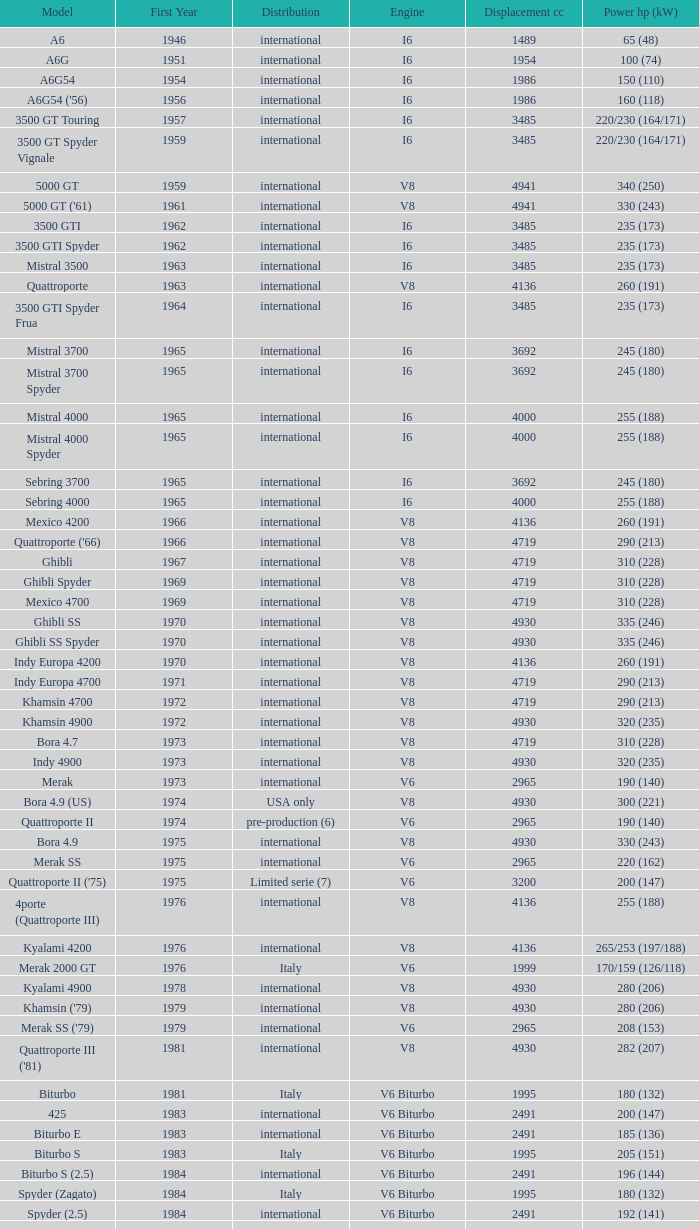What is Power HP (kW), when First Year is greater than 1965, when Distribution is "International", when Engine is V6 Biturbo, and when Model is "425"? 200 (147). Could you parse the entire table? {'header': ['Model', 'First Year', 'Distribution', 'Engine', 'Displacement cc', 'Power hp (kW)'], 'rows': [['A6', '1946', 'international', 'I6', '1489', '65 (48)'], ['A6G', '1951', 'international', 'I6', '1954', '100 (74)'], ['A6G54', '1954', 'international', 'I6', '1986', '150 (110)'], ["A6G54 ('56)", '1956', 'international', 'I6', '1986', '160 (118)'], ['3500 GT Touring', '1957', 'international', 'I6', '3485', '220/230 (164/171)'], ['3500 GT Spyder Vignale', '1959', 'international', 'I6', '3485', '220/230 (164/171)'], ['5000 GT', '1959', 'international', 'V8', '4941', '340 (250)'], ["5000 GT ('61)", '1961', 'international', 'V8', '4941', '330 (243)'], ['3500 GTI', '1962', 'international', 'I6', '3485', '235 (173)'], ['3500 GTI Spyder', '1962', 'international', 'I6', '3485', '235 (173)'], ['Mistral 3500', '1963', 'international', 'I6', '3485', '235 (173)'], ['Quattroporte', '1963', 'international', 'V8', '4136', '260 (191)'], ['3500 GTI Spyder Frua', '1964', 'international', 'I6', '3485', '235 (173)'], ['Mistral 3700', '1965', 'international', 'I6', '3692', '245 (180)'], ['Mistral 3700 Spyder', '1965', 'international', 'I6', '3692', '245 (180)'], ['Mistral 4000', '1965', 'international', 'I6', '4000', '255 (188)'], ['Mistral 4000 Spyder', '1965', 'international', 'I6', '4000', '255 (188)'], ['Sebring 3700', '1965', 'international', 'I6', '3692', '245 (180)'], ['Sebring 4000', '1965', 'international', 'I6', '4000', '255 (188)'], ['Mexico 4200', '1966', 'international', 'V8', '4136', '260 (191)'], ["Quattroporte ('66)", '1966', 'international', 'V8', '4719', '290 (213)'], ['Ghibli', '1967', 'international', 'V8', '4719', '310 (228)'], ['Ghibli Spyder', '1969', 'international', 'V8', '4719', '310 (228)'], ['Mexico 4700', '1969', 'international', 'V8', '4719', '310 (228)'], ['Ghibli SS', '1970', 'international', 'V8', '4930', '335 (246)'], ['Ghibli SS Spyder', '1970', 'international', 'V8', '4930', '335 (246)'], ['Indy Europa 4200', '1970', 'international', 'V8', '4136', '260 (191)'], ['Indy Europa 4700', '1971', 'international', 'V8', '4719', '290 (213)'], ['Khamsin 4700', '1972', 'international', 'V8', '4719', '290 (213)'], ['Khamsin 4900', '1972', 'international', 'V8', '4930', '320 (235)'], ['Bora 4.7', '1973', 'international', 'V8', '4719', '310 (228)'], ['Indy 4900', '1973', 'international', 'V8', '4930', '320 (235)'], ['Merak', '1973', 'international', 'V6', '2965', '190 (140)'], ['Bora 4.9 (US)', '1974', 'USA only', 'V8', '4930', '300 (221)'], ['Quattroporte II', '1974', 'pre-production (6)', 'V6', '2965', '190 (140)'], ['Bora 4.9', '1975', 'international', 'V8', '4930', '330 (243)'], ['Merak SS', '1975', 'international', 'V6', '2965', '220 (162)'], ["Quattroporte II ('75)", '1975', 'Limited serie (7)', 'V6', '3200', '200 (147)'], ['4porte (Quattroporte III)', '1976', 'international', 'V8', '4136', '255 (188)'], ['Kyalami 4200', '1976', 'international', 'V8', '4136', '265/253 (197/188)'], ['Merak 2000 GT', '1976', 'Italy', 'V6', '1999', '170/159 (126/118)'], ['Kyalami 4900', '1978', 'international', 'V8', '4930', '280 (206)'], ["Khamsin ('79)", '1979', 'international', 'V8', '4930', '280 (206)'], ["Merak SS ('79)", '1979', 'international', 'V6', '2965', '208 (153)'], ["Quattroporte III ('81)", '1981', 'international', 'V8', '4930', '282 (207)'], ['Biturbo', '1981', 'Italy', 'V6 Biturbo', '1995', '180 (132)'], ['425', '1983', 'international', 'V6 Biturbo', '2491', '200 (147)'], ['Biturbo E', '1983', 'international', 'V6 Biturbo', '2491', '185 (136)'], ['Biturbo S', '1983', 'Italy', 'V6 Biturbo', '1995', '205 (151)'], ['Biturbo S (2.5)', '1984', 'international', 'V6 Biturbo', '2491', '196 (144)'], ['Spyder (Zagato)', '1984', 'Italy', 'V6 Biturbo', '1995', '180 (132)'], ['Spyder (2.5)', '1984', 'international', 'V6 Biturbo', '2491', '192 (141)'], ['420', '1985', 'Italy', 'V6 Biturbo', '1995', '180 (132)'], ['Biturbo (II)', '1985', 'Italy', 'V6 Biturbo', '1995', '180 (132)'], ['Biturbo E (II 2.5)', '1985', 'international', 'V6 Biturbo', '2491', '185 (136)'], ['Biturbo S (II)', '1985', 'Italy', 'V6 Biturbo', '1995', '210 (154)'], ['228 (228i)', '1986', 'international', 'V6 Biturbo', '2790', '250 (184)'], ['228 (228i) Kat', '1986', 'international', 'V6 Biturbo', '2790', '225 (165)'], ['420i', '1986', 'Italy', 'V6 Biturbo', '1995', '190 (140)'], ['420 S', '1986', 'Italy', 'V6 Biturbo', '1995', '210 (154)'], ['Biturbo i', '1986', 'Italy', 'V6 Biturbo', '1995', '185 (136)'], ['Quattroporte Royale (III)', '1986', 'international', 'V8', '4930', '300 (221)'], ['Spyder i', '1986', 'international', 'V6 Biturbo', '1996', '185 (136)'], ['430', '1987', 'international', 'V6 Biturbo', '2790', '225 (165)'], ['425i', '1987', 'international', 'V6 Biturbo', '2491', '188 (138)'], ['Biturbo Si', '1987', 'Italy', 'V6 Biturbo', '1995', '220 (162)'], ['Biturbo Si (2.5)', '1987', 'international', 'V6 Biturbo', '2491', '188 (138)'], ["Spyder i ('87)", '1987', 'international', 'V6 Biturbo', '1996', '195 (143)'], ['222', '1988', 'Italy', 'V6 Biturbo', '1996', '220 (162)'], ['422', '1988', 'Italy', 'V6 Biturbo', '1996', '220 (162)'], ['2.24V', '1988', 'Italy (probably)', 'V6 Biturbo', '1996', '245 (180)'], ['222 4v', '1988', 'international', 'V6 Biturbo', '2790', '279 (205)'], ['222 E', '1988', 'international', 'V6 Biturbo', '2790', '225 (165)'], ['Karif', '1988', 'international', 'V6 Biturbo', '2790', '285 (210)'], ['Karif (kat)', '1988', 'international', 'V6 Biturbo', '2790', '248 (182)'], ['Karif (kat II)', '1988', 'international', 'V6 Biturbo', '2790', '225 (165)'], ['Spyder i (2.5)', '1988', 'international', 'V6 Biturbo', '2491', '188 (138)'], ['Spyder i (2.8)', '1989', 'international', 'V6 Biturbo', '2790', '250 (184)'], ['Spyder i (2.8, kat)', '1989', 'international', 'V6 Biturbo', '2790', '225 (165)'], ["Spyder i ('90)", '1989', 'Italy', 'V6 Biturbo', '1996', '220 (162)'], ['222 SE', '1990', 'international', 'V6 Biturbo', '2790', '250 (184)'], ['222 SE (kat)', '1990', 'international', 'V6 Biturbo', '2790', '225 (165)'], ['4.18v', '1990', 'Italy', 'V6 Biturbo', '1995', '220 (162)'], ['4.24v', '1990', 'Italy (probably)', 'V6 Biturbo', '1996', '245 (180)'], ['Shamal', '1990', 'international', 'V8 Biturbo', '3217', '326 (240)'], ['2.24v II', '1991', 'Italy', 'V6 Biturbo', '1996', '245 (180)'], ['2.24v II (kat)', '1991', 'international (probably)', 'V6 Biturbo', '1996', '240 (176)'], ['222 SR', '1991', 'international', 'V6 Biturbo', '2790', '225 (165)'], ['4.24v II (kat)', '1991', 'Italy (probably)', 'V6 Biturbo', '1996', '240 (176)'], ['430 4v', '1991', 'international', 'V6 Biturbo', '2790', '279 (205)'], ['Racing', '1991', 'Italy', 'V6 Biturbo', '1996', '283 (208)'], ['Spyder III', '1991', 'Italy', 'V6 Biturbo', '1996', '245 (180)'], ['Spyder III (2.8, kat)', '1991', 'international', 'V6 Biturbo', '2790', '225 (165)'], ['Spyder III (kat)', '1991', 'Italy', 'V6 Biturbo', '1996', '240 (176)'], ['Barchetta Stradale', '1992', 'Prototype', 'V6 Biturbo', '1996', '306 (225)'], ['Barchetta Stradale 2.8', '1992', 'Single, Conversion', 'V6 Biturbo', '2790', '284 (209)'], ['Ghibli II (2.0)', '1992', 'Italy', 'V6 Biturbo', '1996', '306 (225)'], ['Ghibli II (2.8)', '1993', 'international', 'V6 Biturbo', '2790', '284 (209)'], ['Quattroporte (2.0)', '1994', 'Italy', 'V6 Biturbo', '1996', '287 (211)'], ['Quattroporte (2.8)', '1994', 'international', 'V6 Biturbo', '2790', '284 (209)'], ['Ghibli Cup', '1995', 'international', 'V6 Biturbo', '1996', '330 (243)'], ['Quattroporte Ottocilindri', '1995', 'international', 'V8 Biturbo', '3217', '335 (246)'], ['Ghibli Primatist', '1996', 'international', 'V6 Biturbo', '1996', '306 (225)'], ['3200 GT', '1998', 'international', 'V8 Biturbo', '3217', '370 (272)'], ['Quattroporte V6 Evoluzione', '1998', 'international', 'V6 Biturbo', '2790', '284 (209)'], ['Quattroporte V8 Evoluzione', '1998', 'international', 'V8 Biturbo', '3217', '335 (246)'], ['3200 GTA', '2000', 'international', 'V8 Biturbo', '3217', '368 (271)'], ['Spyder GT', '2001', 'international', 'V8', '4244', '390 (287)'], ['Spyder CC', '2001', 'international', 'V8', '4244', '390 (287)'], ['Coupé GT', '2001', 'international', 'V8', '4244', '390 (287)'], ['Coupé CC', '2001', 'international', 'V8', '4244', '390 (287)'], ['Gran Sport', '2002', 'international', 'V8', '4244', '400 (294)'], ['Quattroporte V', '2004', 'international', 'V8', '4244', '400 (294)'], ['MC12 (aka MCC)', '2004', 'Limited', 'V12', '5998', '630 (463)'], ['GranTurismo', '2008', 'international', 'V8', '4244', '405'], ['GranCabrio', '2010', 'international', 'V8', '4691', '433']]} 